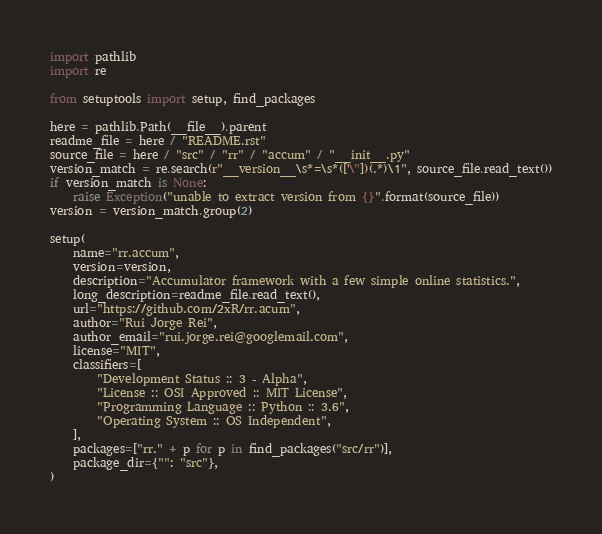Convert code to text. <code><loc_0><loc_0><loc_500><loc_500><_Python_>import pathlib
import re

from setuptools import setup, find_packages

here = pathlib.Path(__file__).parent
readme_file = here / "README.rst"
source_file = here / "src" / "rr" / "accum" / "__init__.py"
version_match = re.search(r"__version__\s*=\s*(['\"])(.*)\1", source_file.read_text())
if version_match is None:
    raise Exception("unable to extract version from {}".format(source_file))
version = version_match.group(2)

setup(
    name="rr.accum",
    version=version,
    description="Accumulator framework with a few simple online statistics.",
    long_description=readme_file.read_text(),
    url="https://github.com/2xR/rr.acum",
    author="Rui Jorge Rei",
    author_email="rui.jorge.rei@googlemail.com",
    license="MIT",
    classifiers=[
        "Development Status :: 3 - Alpha",
        "License :: OSI Approved :: MIT License",
        "Programming Language :: Python :: 3.6",
        "Operating System :: OS Independent",
    ],
    packages=["rr." + p for p in find_packages("src/rr")],
    package_dir={"": "src"},
)
</code> 